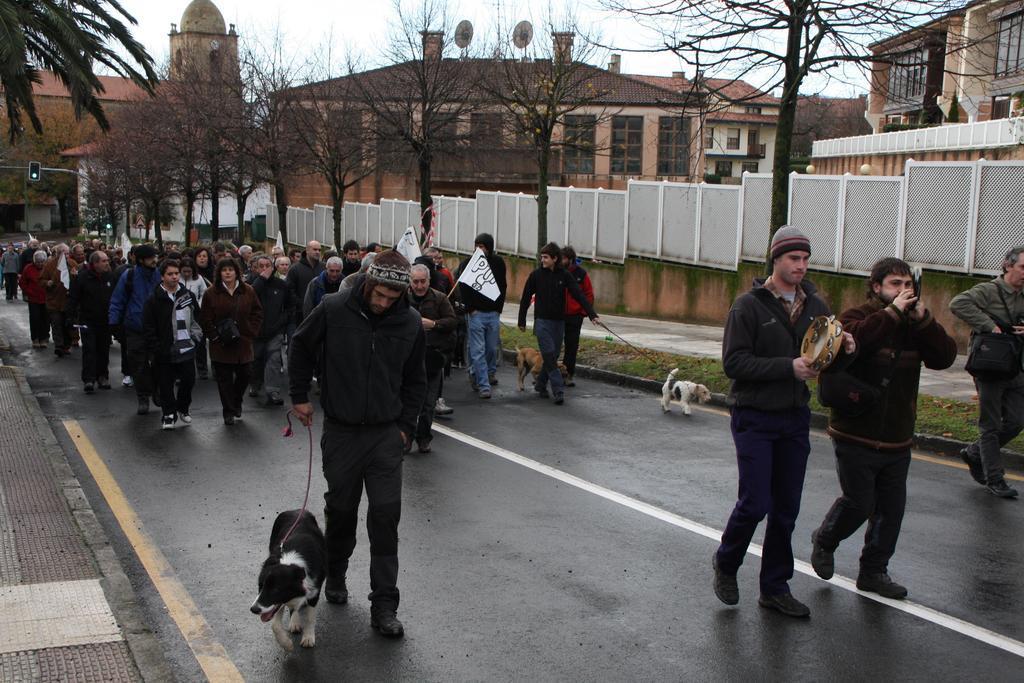How would you summarize this image in a sentence or two? In the picture we can see a road on it, we can see many people are walking with a dog and belts to it and in the background, we can see a wall and some dried trees near it and behind it we can see buildings and windows in it and in the background we can see a sky. 